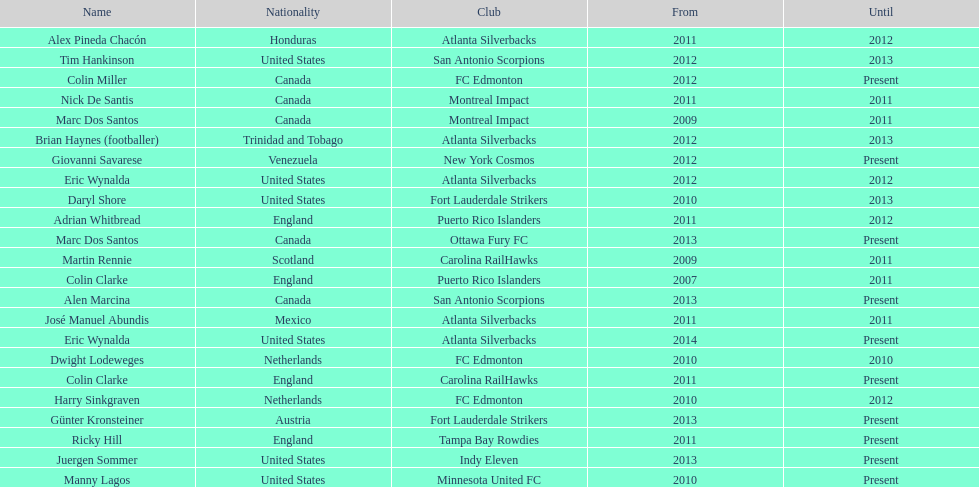Who was the coach of fc edmonton before miller? Harry Sinkgraven. 